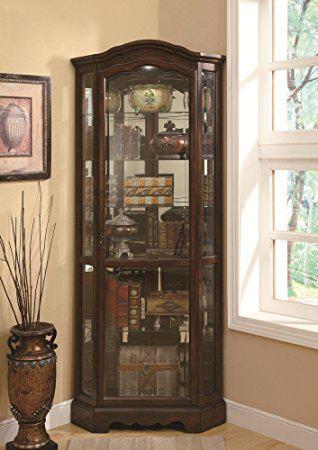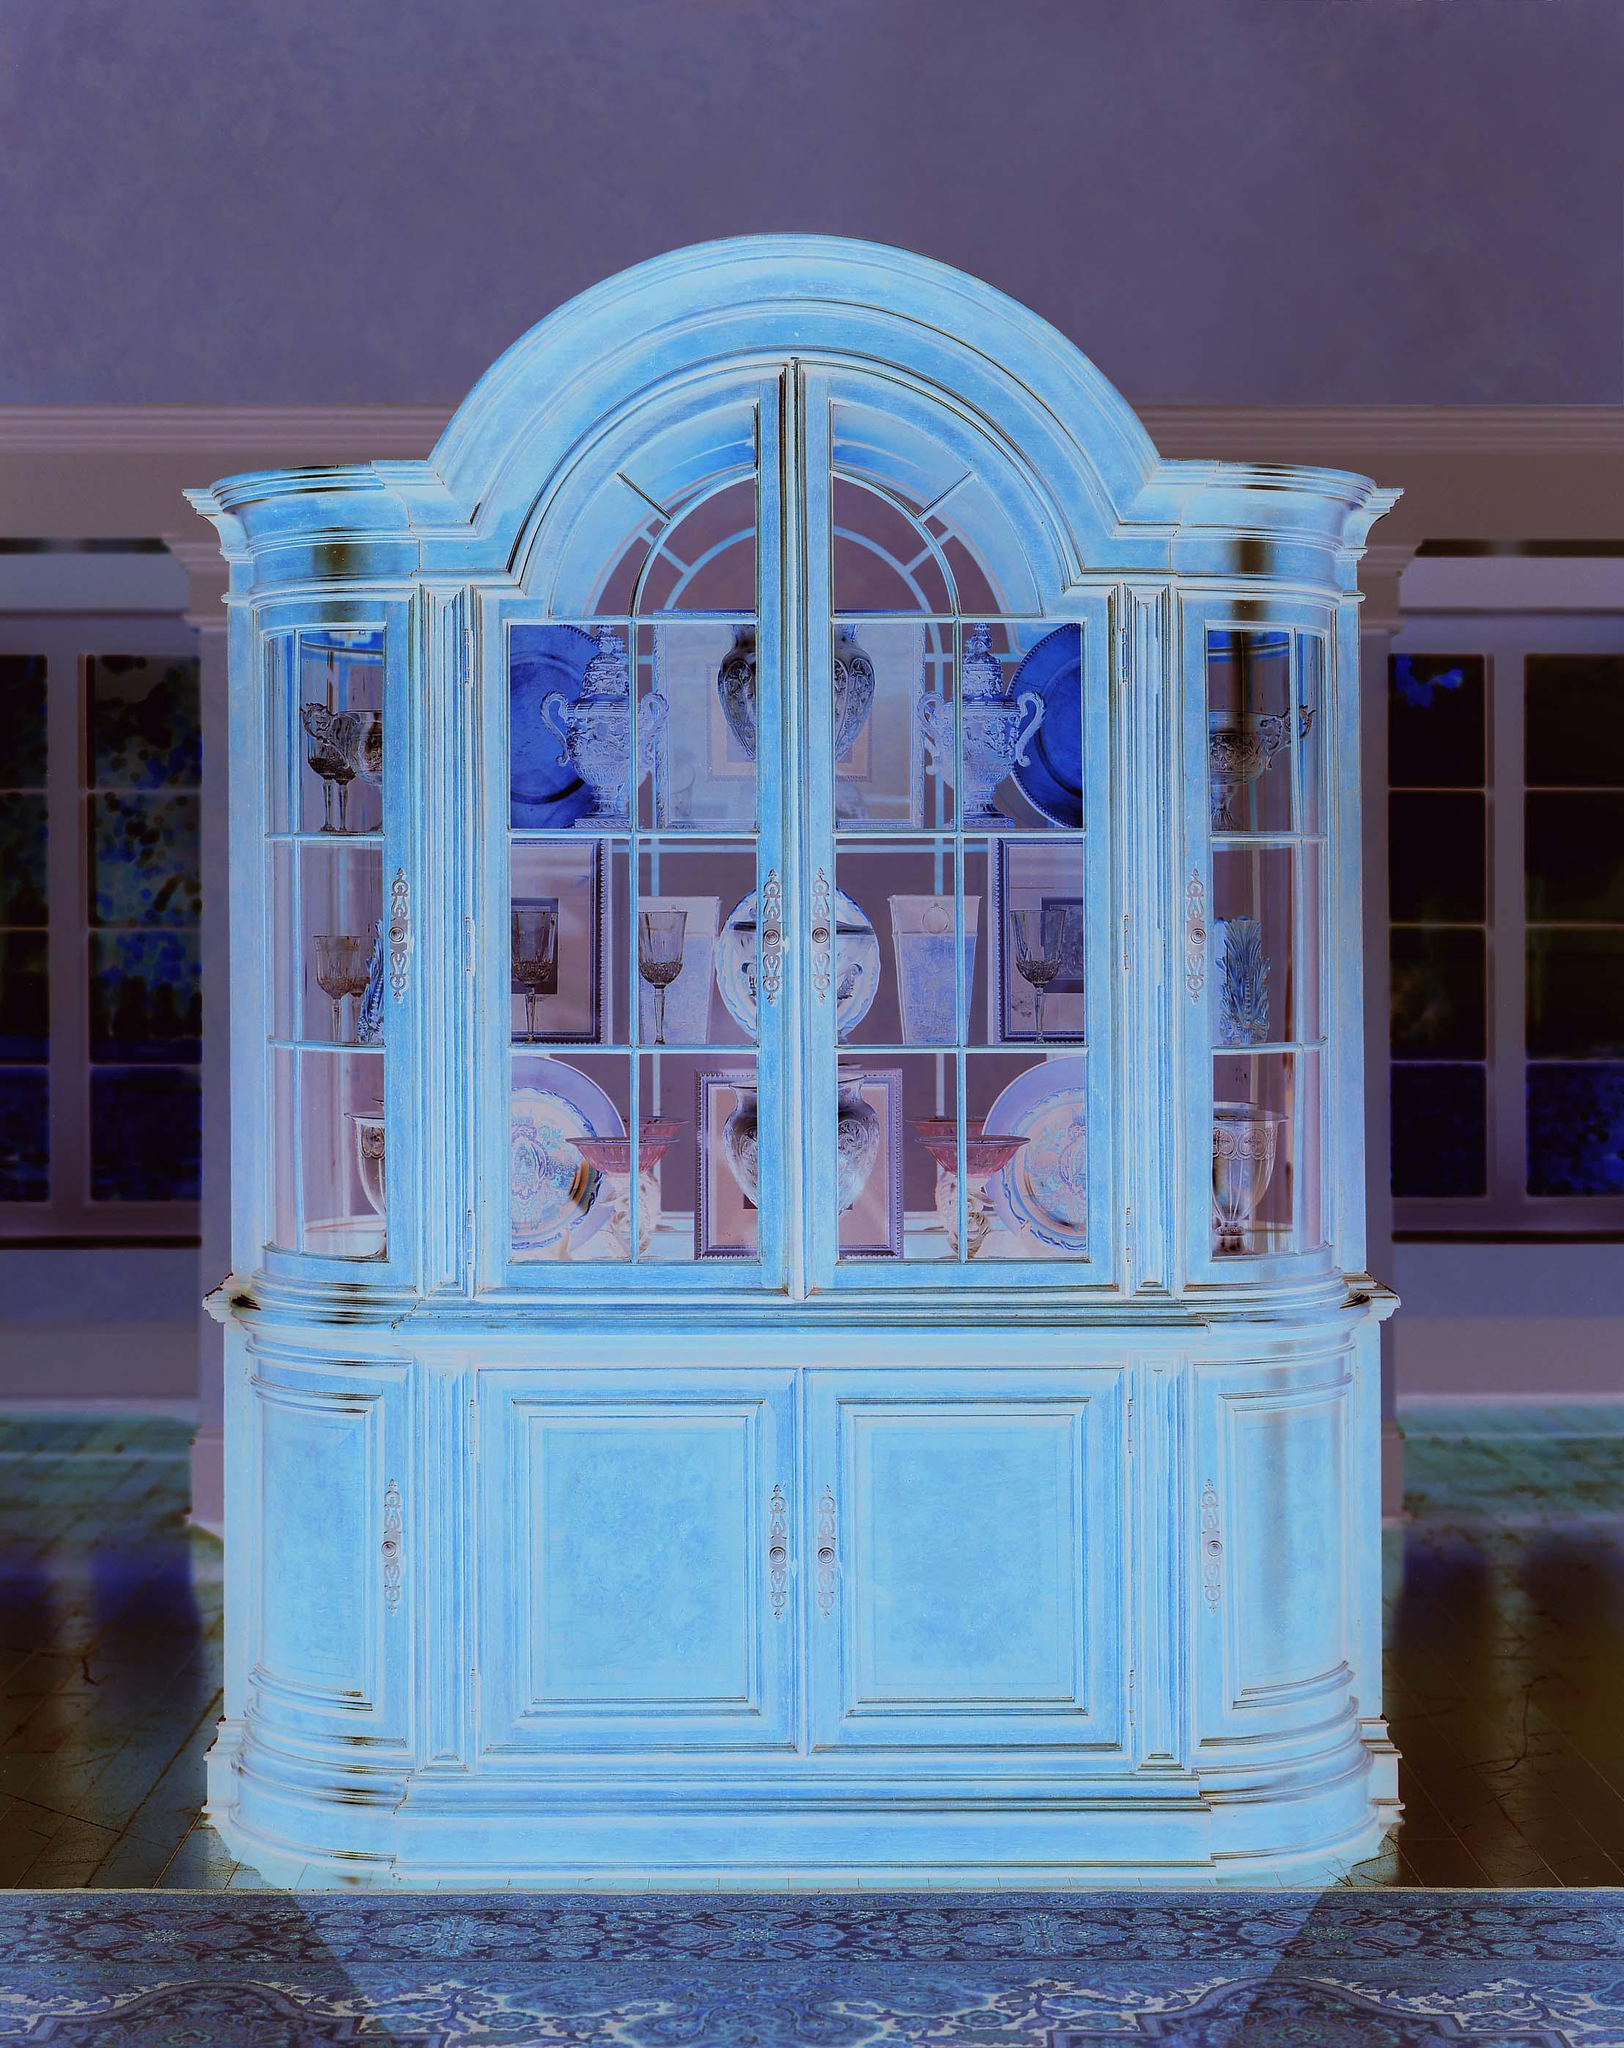The first image is the image on the left, the second image is the image on the right. Given the left and right images, does the statement "Wooden china cabinets in both images are dark and ornate with curved details." hold true? Answer yes or no. No. The first image is the image on the left, the second image is the image on the right. For the images displayed, is the sentence "There is a brown chair with white seat." factually correct? Answer yes or no. No. 